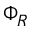Convert formula to latex. <formula><loc_0><loc_0><loc_500><loc_500>\Phi _ { R }</formula> 